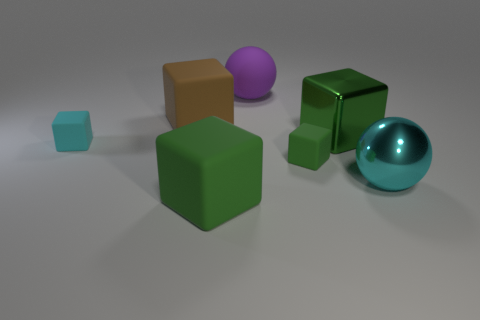How many green blocks must be subtracted to get 1 green blocks? 2 Subtract all brown rubber cubes. How many cubes are left? 4 Subtract all cyan blocks. How many blocks are left? 4 Add 1 green shiny cubes. How many objects exist? 8 Subtract all gray cylinders. How many green blocks are left? 3 Subtract all cubes. How many objects are left? 2 Subtract all gray cubes. Subtract all gray balls. How many cubes are left? 5 Subtract all small gray matte blocks. Subtract all cyan shiny objects. How many objects are left? 6 Add 3 tiny cubes. How many tiny cubes are left? 5 Add 3 cyan spheres. How many cyan spheres exist? 4 